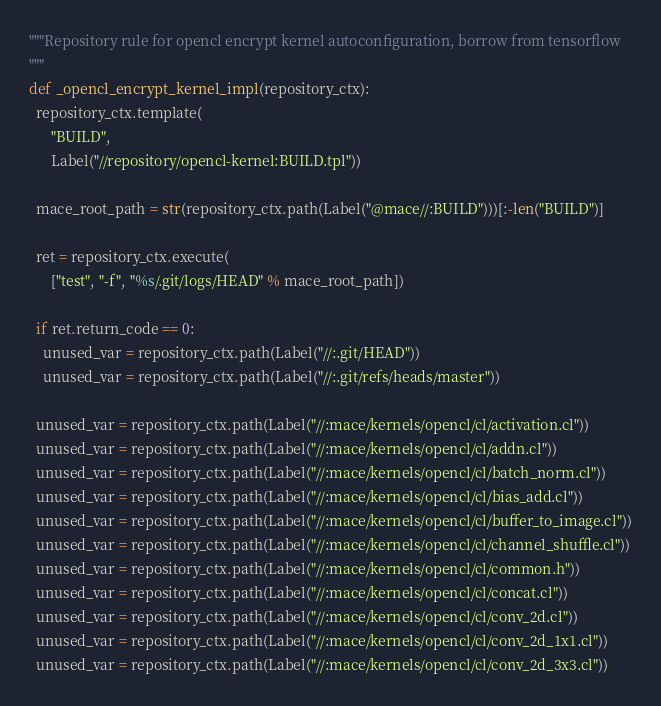Convert code to text. <code><loc_0><loc_0><loc_500><loc_500><_Python_>"""Repository rule for opencl encrypt kernel autoconfiguration, borrow from tensorflow
"""
def _opencl_encrypt_kernel_impl(repository_ctx):
  repository_ctx.template(
      "BUILD",
      Label("//repository/opencl-kernel:BUILD.tpl"))

  mace_root_path = str(repository_ctx.path(Label("@mace//:BUILD")))[:-len("BUILD")]

  ret = repository_ctx.execute(
      ["test", "-f", "%s/.git/logs/HEAD" % mace_root_path])

  if ret.return_code == 0:
    unused_var = repository_ctx.path(Label("//:.git/HEAD"))
    unused_var = repository_ctx.path(Label("//:.git/refs/heads/master"))

  unused_var = repository_ctx.path(Label("//:mace/kernels/opencl/cl/activation.cl"))
  unused_var = repository_ctx.path(Label("//:mace/kernels/opencl/cl/addn.cl"))
  unused_var = repository_ctx.path(Label("//:mace/kernels/opencl/cl/batch_norm.cl"))
  unused_var = repository_ctx.path(Label("//:mace/kernels/opencl/cl/bias_add.cl"))
  unused_var = repository_ctx.path(Label("//:mace/kernels/opencl/cl/buffer_to_image.cl"))
  unused_var = repository_ctx.path(Label("//:mace/kernels/opencl/cl/channel_shuffle.cl"))
  unused_var = repository_ctx.path(Label("//:mace/kernels/opencl/cl/common.h"))
  unused_var = repository_ctx.path(Label("//:mace/kernels/opencl/cl/concat.cl"))
  unused_var = repository_ctx.path(Label("//:mace/kernels/opencl/cl/conv_2d.cl"))
  unused_var = repository_ctx.path(Label("//:mace/kernels/opencl/cl/conv_2d_1x1.cl"))
  unused_var = repository_ctx.path(Label("//:mace/kernels/opencl/cl/conv_2d_3x3.cl"))</code> 